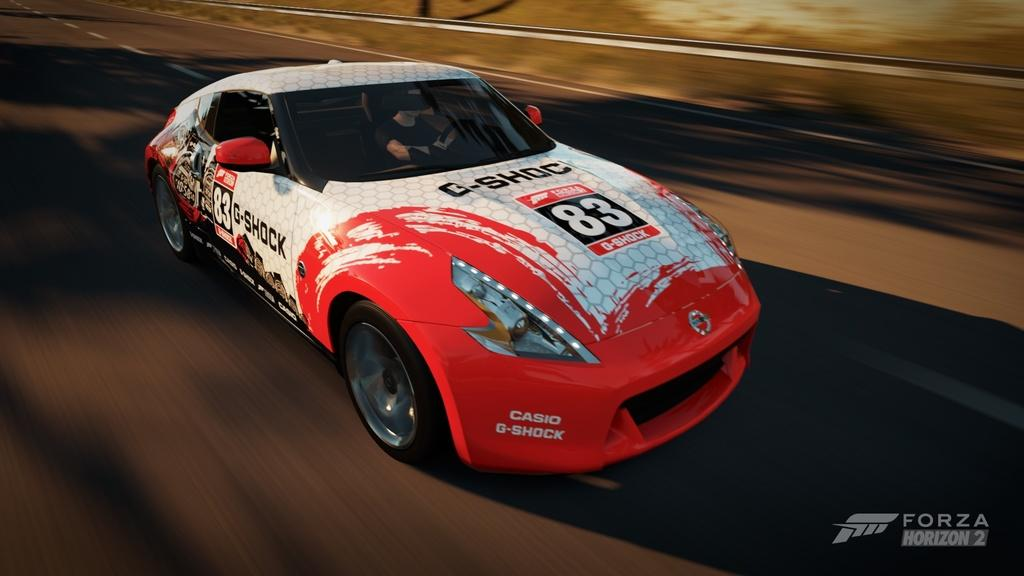What is the person in the image doing? There is a person sitting inside a car in the image. Where is the car located? The car is placed on the road. What can be seen in the background of the image? There is a metal barrier in the background of the image. Is there any text visible in the image? Yes, there is some text visible at the bottom of the image. What type of apparel is the goldfish wearing in the image? There is no goldfish present in the image, and therefore no apparel can be observed. How does the person in the car turn the vehicle in the image? The question assumes that the person is driving the car, but we cannot determine that from the provided facts. The image only shows the person sitting inside the car. 